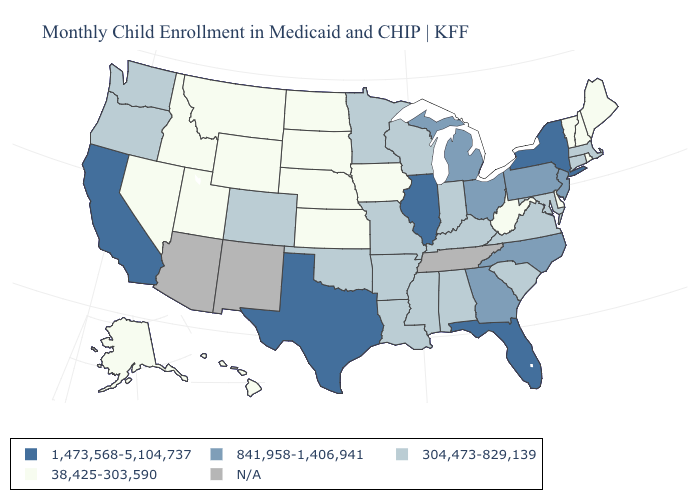Which states have the lowest value in the USA?
Quick response, please. Alaska, Delaware, Hawaii, Idaho, Iowa, Kansas, Maine, Montana, Nebraska, Nevada, New Hampshire, North Dakota, Rhode Island, South Dakota, Utah, Vermont, West Virginia, Wyoming. Is the legend a continuous bar?
Quick response, please. No. Among the states that border Wyoming , does Colorado have the highest value?
Give a very brief answer. Yes. Does North Carolina have the highest value in the USA?
Give a very brief answer. No. What is the value of Mississippi?
Short answer required. 304,473-829,139. What is the value of Alaska?
Be succinct. 38,425-303,590. Among the states that border Texas , which have the highest value?
Be succinct. Arkansas, Louisiana, Oklahoma. What is the value of West Virginia?
Answer briefly. 38,425-303,590. What is the value of Illinois?
Concise answer only. 1,473,568-5,104,737. Name the states that have a value in the range 841,958-1,406,941?
Give a very brief answer. Georgia, Michigan, New Jersey, North Carolina, Ohio, Pennsylvania. Name the states that have a value in the range 1,473,568-5,104,737?
Be succinct. California, Florida, Illinois, New York, Texas. What is the highest value in the West ?
Give a very brief answer. 1,473,568-5,104,737. Does the map have missing data?
Short answer required. Yes. 